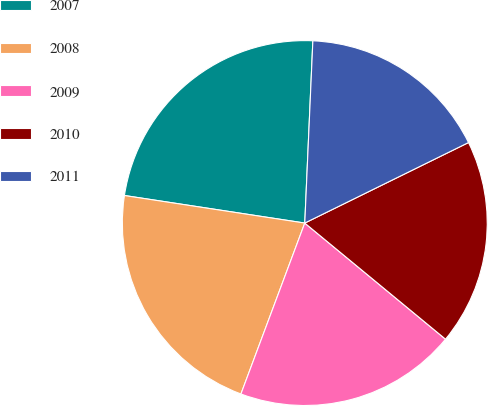Convert chart to OTSL. <chart><loc_0><loc_0><loc_500><loc_500><pie_chart><fcel>2007<fcel>2008<fcel>2009<fcel>2010<fcel>2011<nl><fcel>23.29%<fcel>21.72%<fcel>19.71%<fcel>18.25%<fcel>17.02%<nl></chart> 